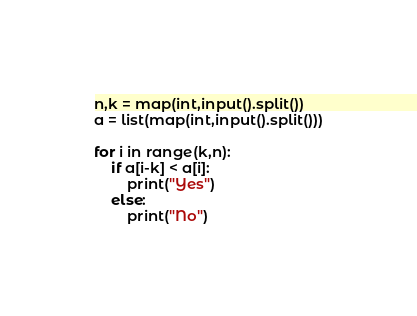<code> <loc_0><loc_0><loc_500><loc_500><_Python_>n,k = map(int,input().split())
a = list(map(int,input().split()))

for i in range(k,n):
    if a[i-k] < a[i]:
        print("Yes")
    else:
        print("No")

</code> 